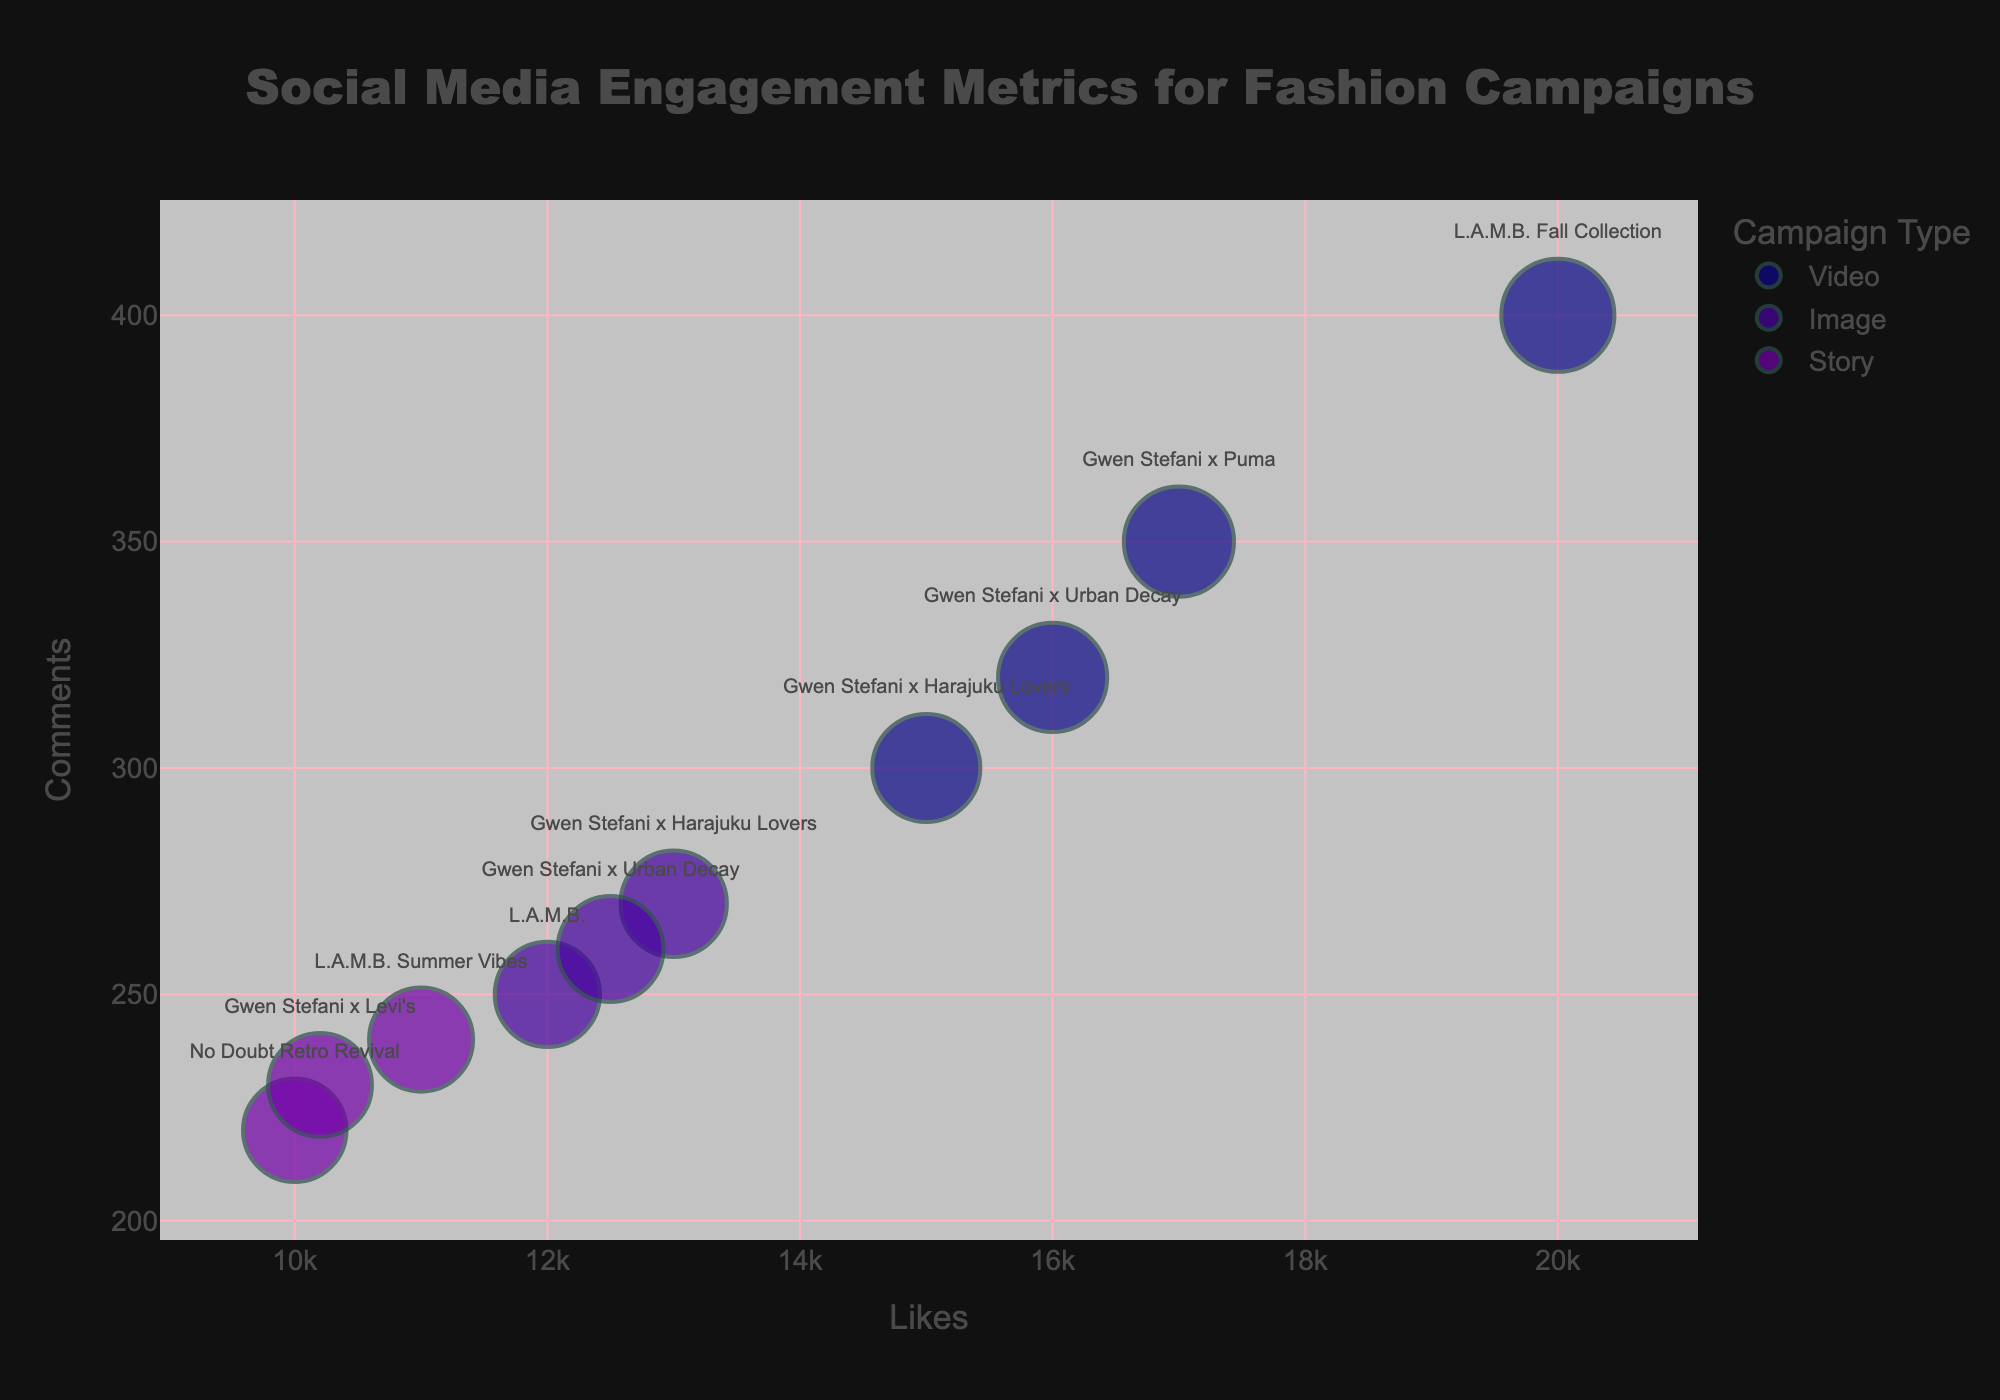What's the title of the figure? The title is usually placed prominently at the top of the chart. In this bubble chart, the title is easily visible.
Answer: Social Media Engagement Metrics for Fashion Campaigns How many campaign types are represented in the chart? The legend on the right side of the chart lists the campaign types. By counting the different types, we see there are three.
Answer: 3 Which campaign type has the smallest bubble size? Bubble size is proportional to the impressions; smaller bubbles indicate fewer impressions. By examining the chart, we can identify the smallest bubble.
Answer: Story Which campaign has the highest number of likes? The x-axis represents the likes, and the rightmost bubble on that axis corresponds to the highest number of likes.
Answer: L.A.M.B. Fall Collection What is the color associated with the 'Video' campaign type? The legend indicates the colors associated with each campaign type. By checking the legend, we see 'Video' is represented by a specific color.
Answer: Orange/Yellowish What is the approximate average number of comments for 'Image' type campaigns? We need to find the data points for 'Image' campaigns and calculate their average comments. The data points are 250, 270, and 260. The average is (250 + 270 + 260)/3.
Answer: 260 Which campaign has the highest engagement in terms of comments? The y-axis represents the comments, and the bubble highest on the y-axis corresponds to the highest number of comments.
Answer: L.A.M.B. Fall Collection How does the engagement in shares for 'Gwen Stefani x Harajuku Lovers' Image compare to its Video campaign? Compare the bubble for the 'Image' of 'Gwen Stefani x Harajuku Lovers' to the bubble for the 'Video' in terms of the z (bubble size) which reflects shares. The data tells Image has 1600 shares and Video has 2000 shares.
Answer: The Video campaign has more shares Which campaign shows the highest impressions? The size of the bubble indicates impressions; the largest bubble corresponds to the highest impressions.
Answer: L.A.M.B. Fall Collection What is the unique visual feature of the bubbles in this bubble chart? Each bubble is partly transparent, allowing us to see overlapping areas and better understand the density of data points. This is a distinctive visual feature.
Answer: Transparency 